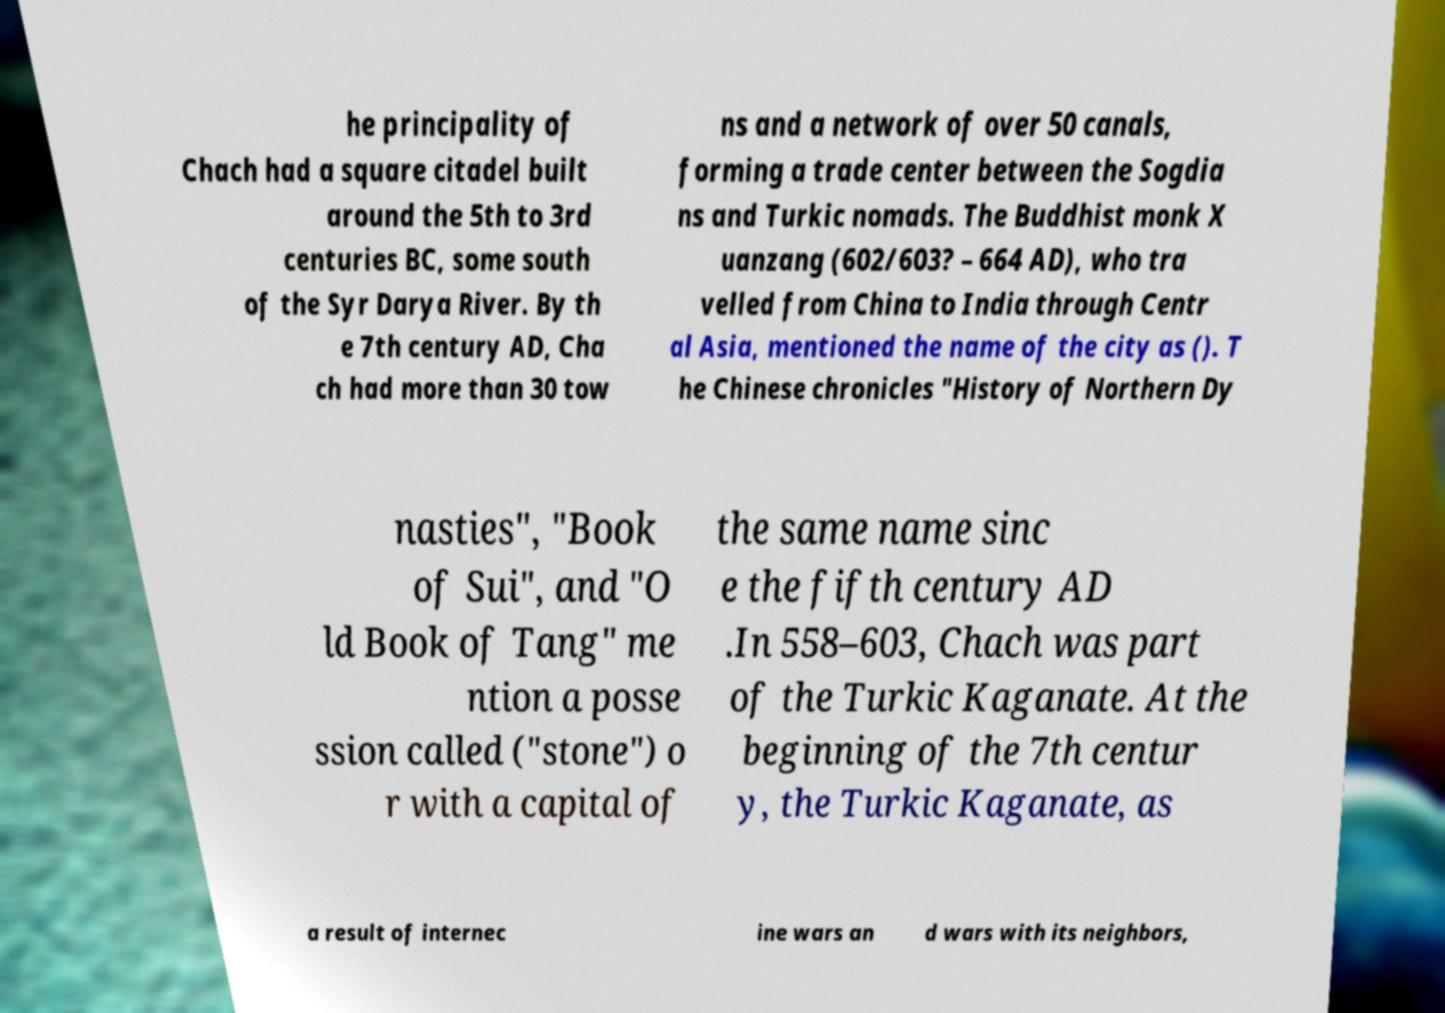Could you extract and type out the text from this image? he principality of Chach had a square citadel built around the 5th to 3rd centuries BC, some south of the Syr Darya River. By th e 7th century AD, Cha ch had more than 30 tow ns and a network of over 50 canals, forming a trade center between the Sogdia ns and Turkic nomads. The Buddhist monk X uanzang (602/603? – 664 AD), who tra velled from China to India through Centr al Asia, mentioned the name of the city as (). T he Chinese chronicles "History of Northern Dy nasties", "Book of Sui", and "O ld Book of Tang" me ntion a posse ssion called ("stone") o r with a capital of the same name sinc e the fifth century AD .In 558–603, Chach was part of the Turkic Kaganate. At the beginning of the 7th centur y, the Turkic Kaganate, as a result of internec ine wars an d wars with its neighbors, 